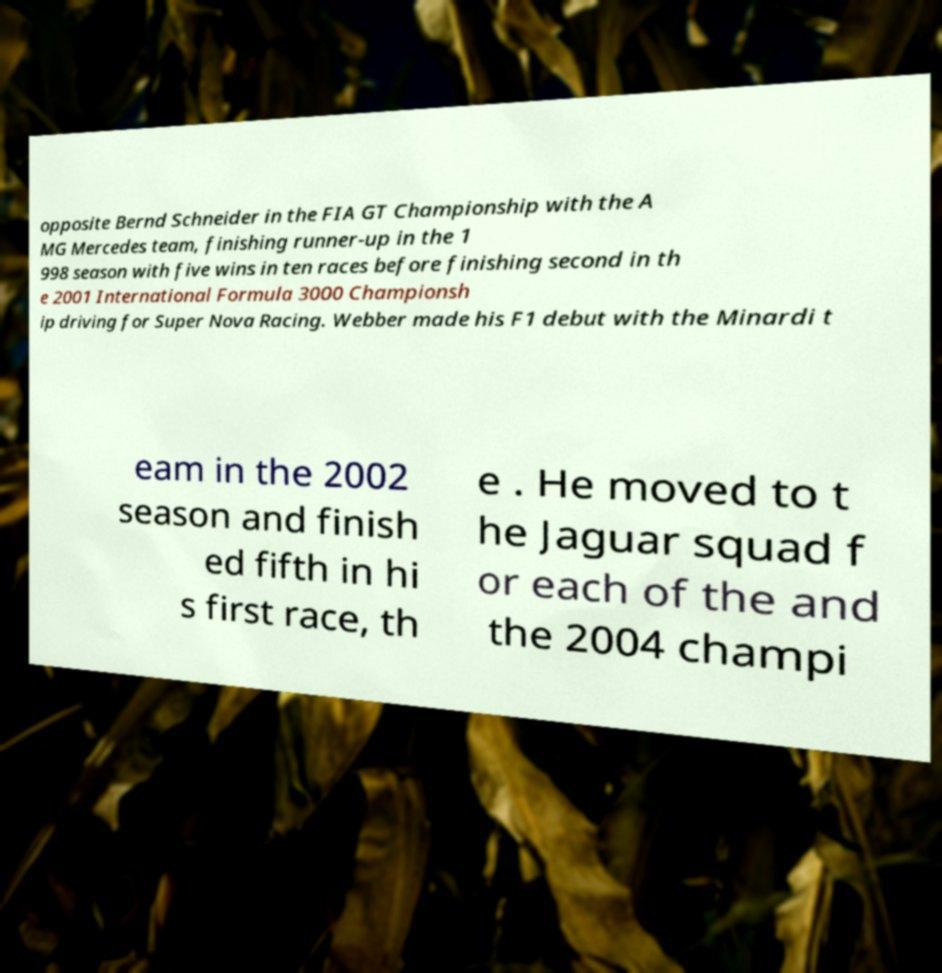I need the written content from this picture converted into text. Can you do that? opposite Bernd Schneider in the FIA GT Championship with the A MG Mercedes team, finishing runner-up in the 1 998 season with five wins in ten races before finishing second in th e 2001 International Formula 3000 Championsh ip driving for Super Nova Racing. Webber made his F1 debut with the Minardi t eam in the 2002 season and finish ed fifth in hi s first race, th e . He moved to t he Jaguar squad f or each of the and the 2004 champi 